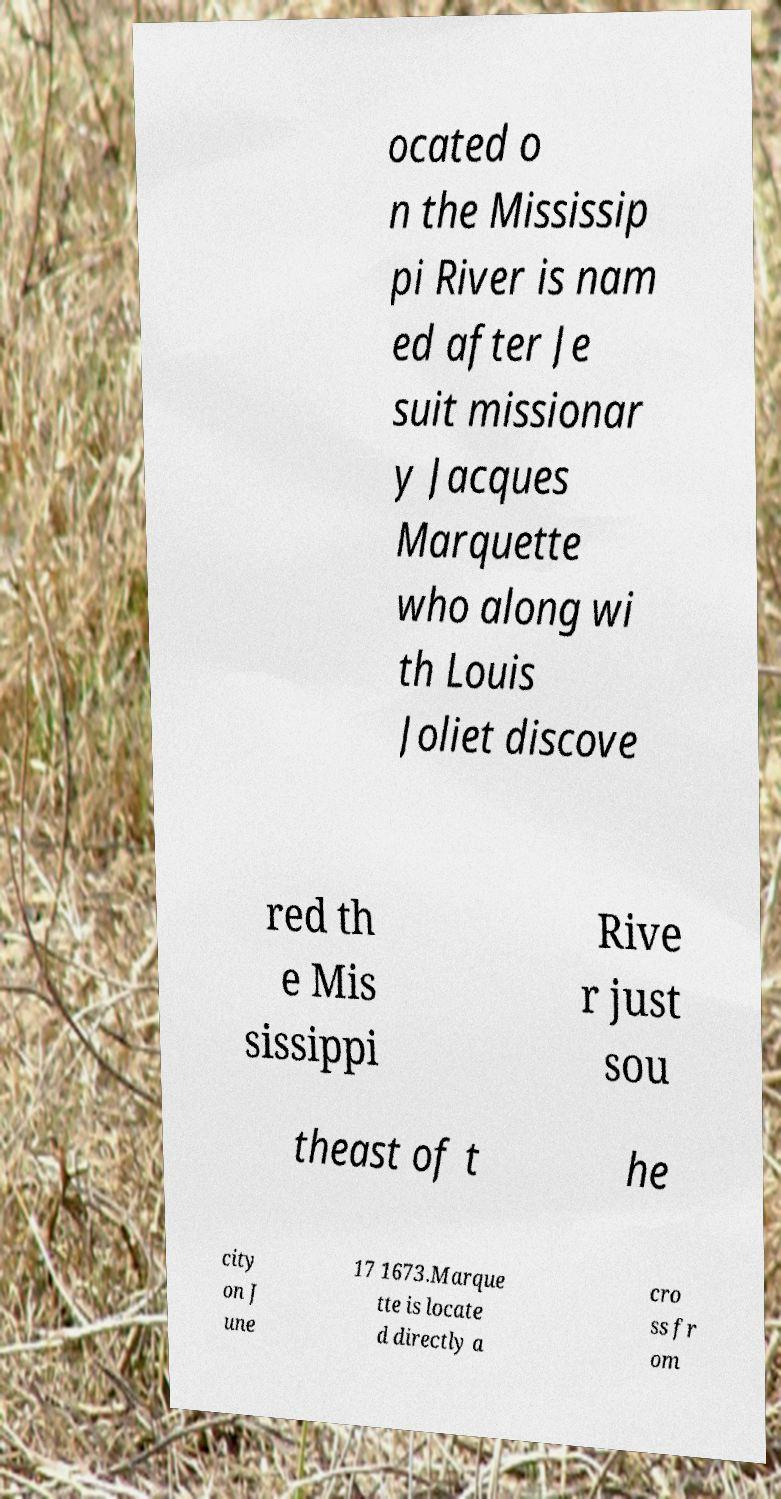Could you extract and type out the text from this image? ocated o n the Mississip pi River is nam ed after Je suit missionar y Jacques Marquette who along wi th Louis Joliet discove red th e Mis sissippi Rive r just sou theast of t he city on J une 17 1673.Marque tte is locate d directly a cro ss fr om 